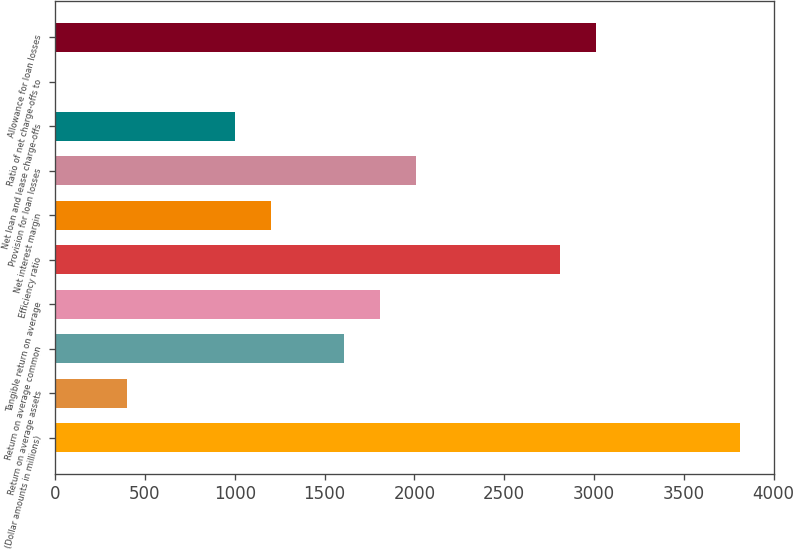<chart> <loc_0><loc_0><loc_500><loc_500><bar_chart><fcel>(Dollar amounts in millions)<fcel>Return on average assets<fcel>Return on average common<fcel>Tangible return on average<fcel>Efficiency ratio<fcel>Net interest margin<fcel>Provision for loan losses<fcel>Net loan and lease charge-offs<fcel>Ratio of net charge-offs to<fcel>Allowance for loan losses<nl><fcel>3813.2<fcel>401.47<fcel>1605.61<fcel>1806.3<fcel>2809.75<fcel>1204.23<fcel>2006.99<fcel>1003.54<fcel>0.09<fcel>3010.44<nl></chart> 